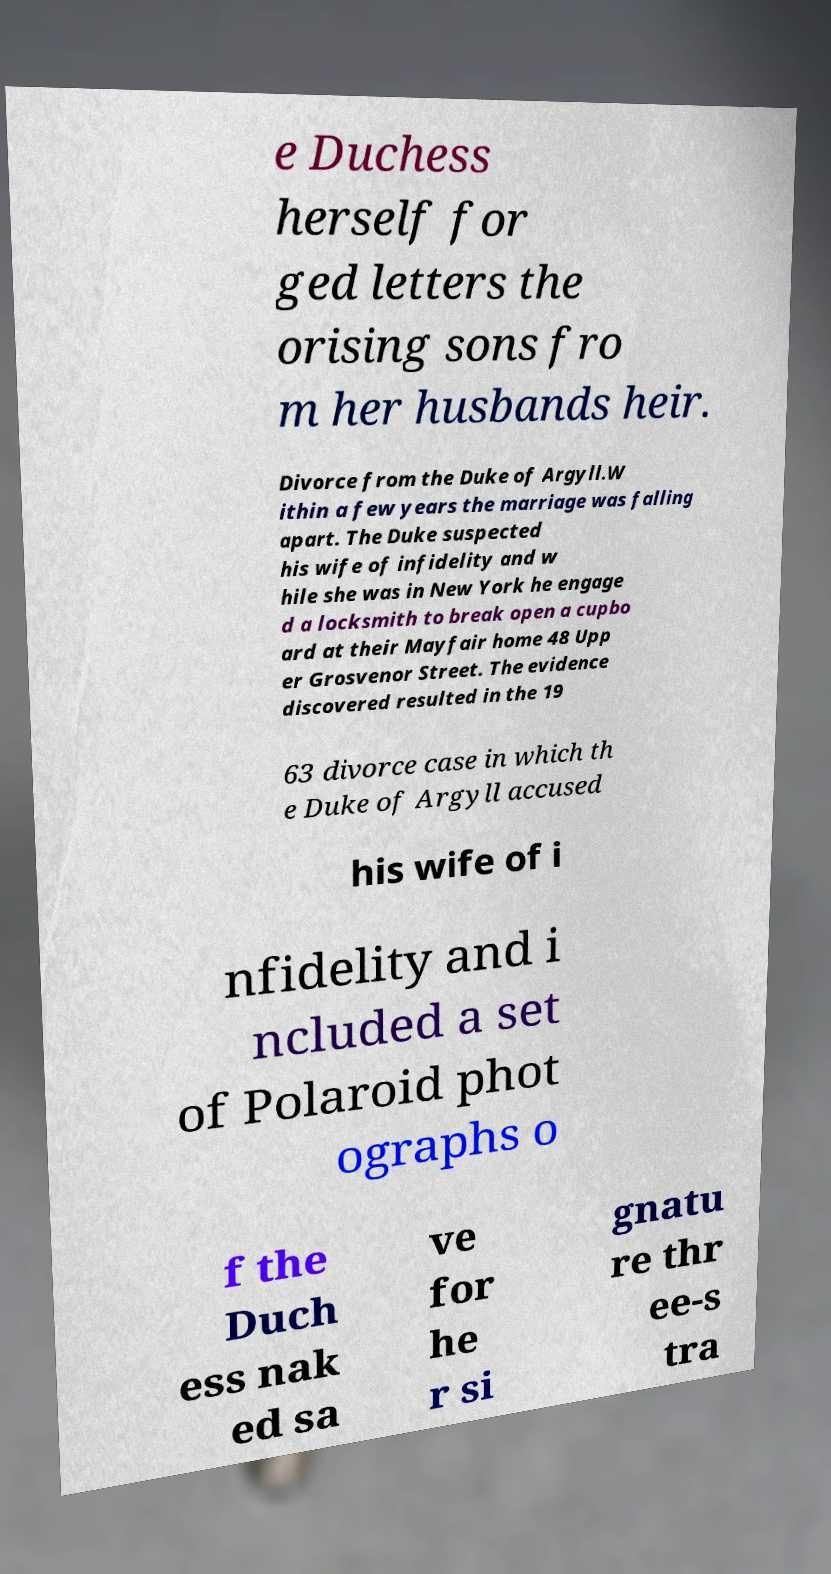Please identify and transcribe the text found in this image. e Duchess herself for ged letters the orising sons fro m her husbands heir. Divorce from the Duke of Argyll.W ithin a few years the marriage was falling apart. The Duke suspected his wife of infidelity and w hile she was in New York he engage d a locksmith to break open a cupbo ard at their Mayfair home 48 Upp er Grosvenor Street. The evidence discovered resulted in the 19 63 divorce case in which th e Duke of Argyll accused his wife of i nfidelity and i ncluded a set of Polaroid phot ographs o f the Duch ess nak ed sa ve for he r si gnatu re thr ee-s tra 